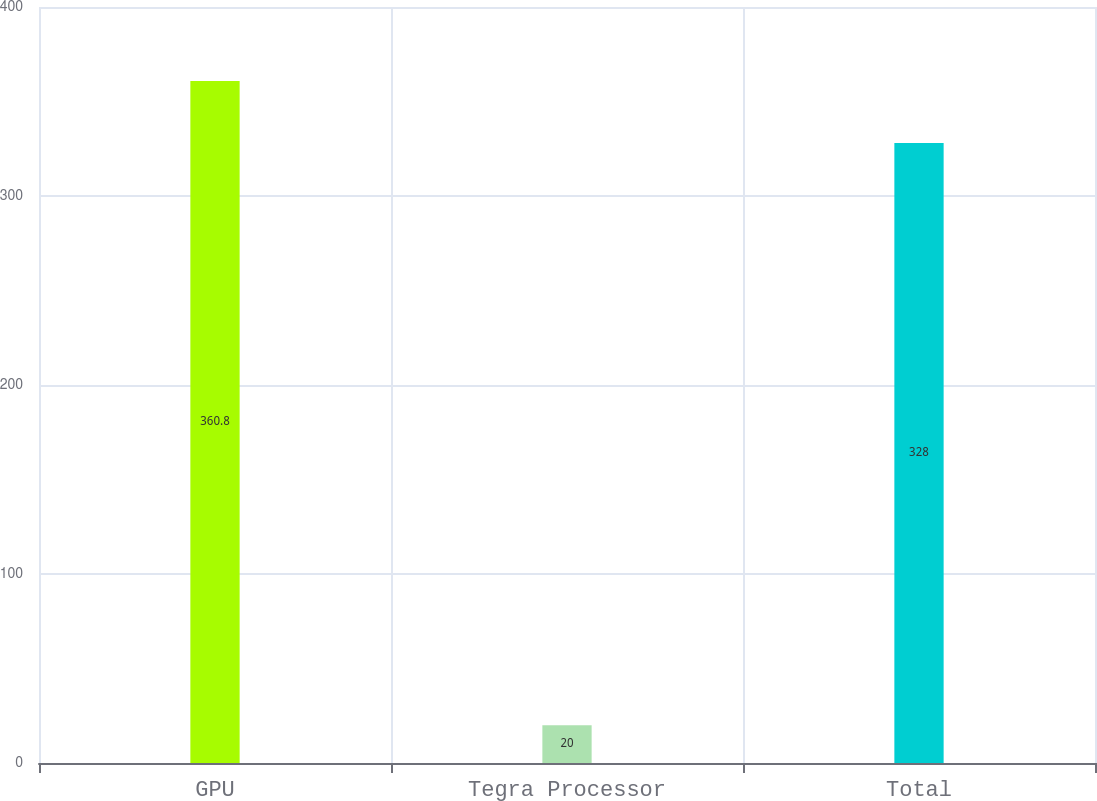Convert chart to OTSL. <chart><loc_0><loc_0><loc_500><loc_500><bar_chart><fcel>GPU<fcel>Tegra Processor<fcel>Total<nl><fcel>360.8<fcel>20<fcel>328<nl></chart> 